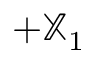<formula> <loc_0><loc_0><loc_500><loc_500>+ { \mathbb { X } } _ { 1 }</formula> 